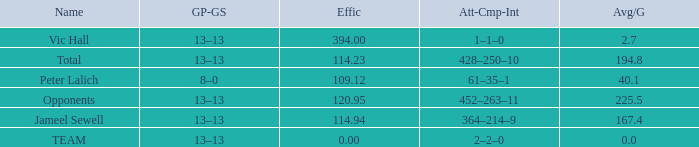Avg/G that has a GP-GS of 13–13, and a Effic smaller than 114.23 has what total of numbers? 1.0. 